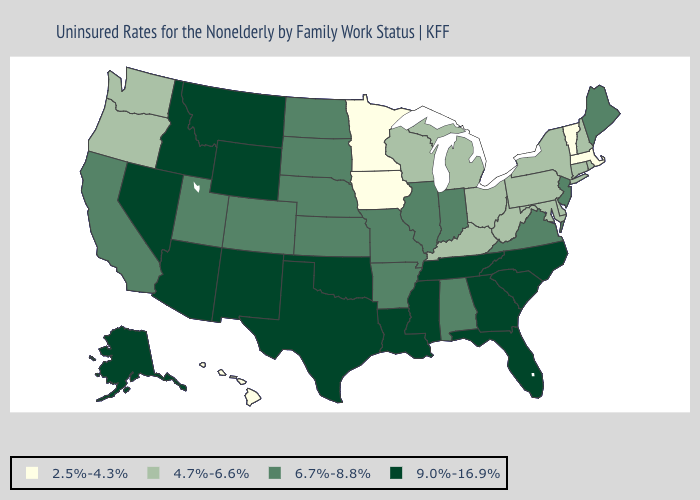Name the states that have a value in the range 9.0%-16.9%?
Quick response, please. Alaska, Arizona, Florida, Georgia, Idaho, Louisiana, Mississippi, Montana, Nevada, New Mexico, North Carolina, Oklahoma, South Carolina, Tennessee, Texas, Wyoming. What is the value of Colorado?
Be succinct. 6.7%-8.8%. What is the lowest value in the USA?
Answer briefly. 2.5%-4.3%. Name the states that have a value in the range 9.0%-16.9%?
Write a very short answer. Alaska, Arizona, Florida, Georgia, Idaho, Louisiana, Mississippi, Montana, Nevada, New Mexico, North Carolina, Oklahoma, South Carolina, Tennessee, Texas, Wyoming. What is the value of Louisiana?
Answer briefly. 9.0%-16.9%. Does New York have the highest value in the Northeast?
Concise answer only. No. How many symbols are there in the legend?
Quick response, please. 4. Name the states that have a value in the range 2.5%-4.3%?
Short answer required. Hawaii, Iowa, Massachusetts, Minnesota, Vermont. What is the highest value in states that border South Dakota?
Give a very brief answer. 9.0%-16.9%. What is the value of Georgia?
Give a very brief answer. 9.0%-16.9%. What is the highest value in the West ?
Concise answer only. 9.0%-16.9%. Does Maryland have the highest value in the USA?
Quick response, please. No. Does Missouri have the lowest value in the MidWest?
Answer briefly. No. Name the states that have a value in the range 4.7%-6.6%?
Answer briefly. Connecticut, Delaware, Kentucky, Maryland, Michigan, New Hampshire, New York, Ohio, Oregon, Pennsylvania, Rhode Island, Washington, West Virginia, Wisconsin. Does Wisconsin have the highest value in the MidWest?
Short answer required. No. 